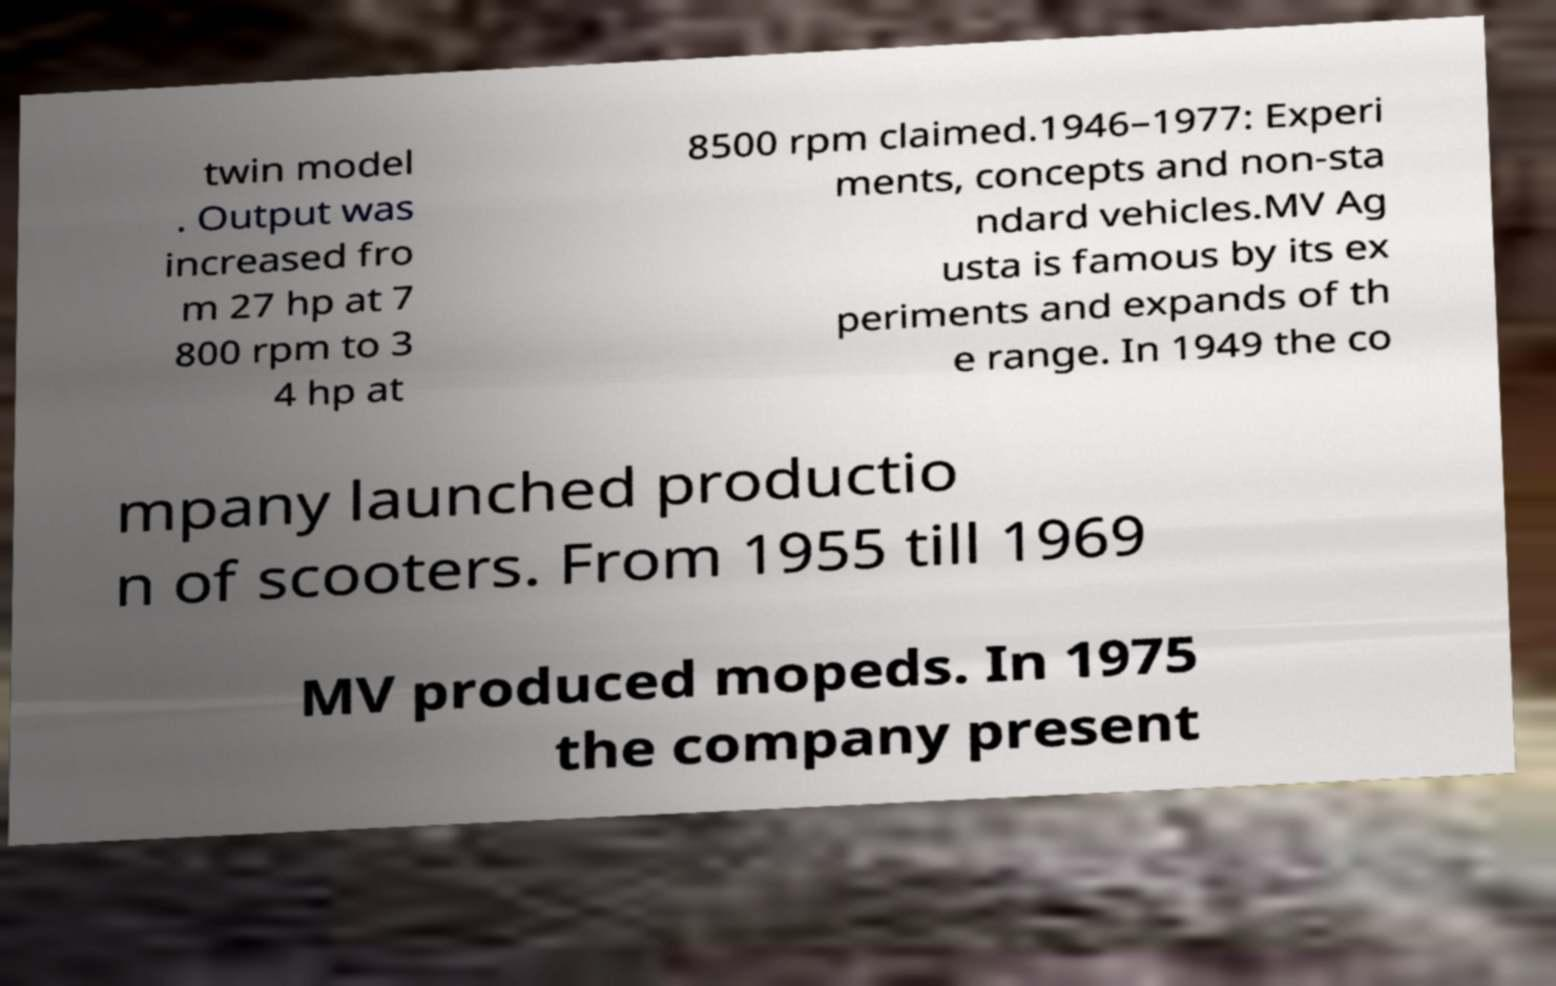Could you assist in decoding the text presented in this image and type it out clearly? twin model . Output was increased fro m 27 hp at 7 800 rpm to 3 4 hp at 8500 rpm claimed.1946–1977: Experi ments, concepts and non-sta ndard vehicles.MV Ag usta is famous by its ex periments and expands of th e range. In 1949 the co mpany launched productio n of scooters. From 1955 till 1969 MV produced mopeds. In 1975 the company present 